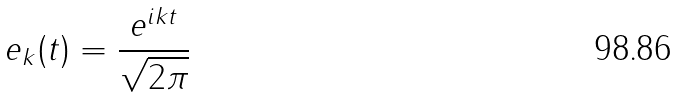<formula> <loc_0><loc_0><loc_500><loc_500>e _ { k } ( t ) = \frac { e ^ { i k t } } { \sqrt { 2 \pi } }</formula> 